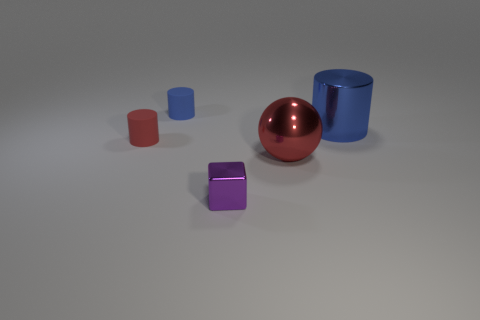Which object appears to be closest to the point of view of the camera? The red glossy cylinder appears to be closest to the camera's point of view. 